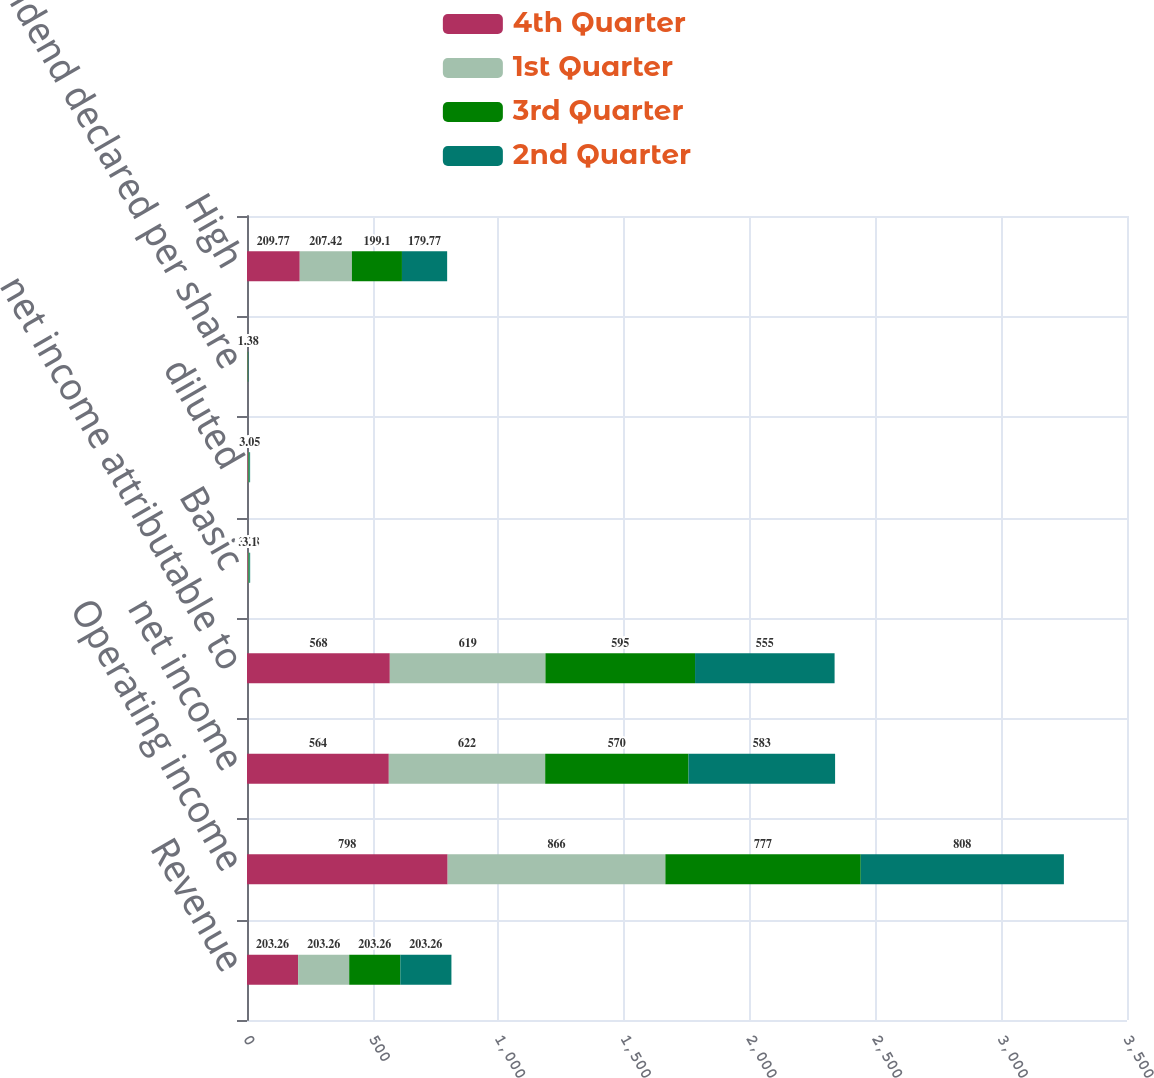Convert chart to OTSL. <chart><loc_0><loc_0><loc_500><loc_500><stacked_bar_chart><ecel><fcel>Revenue<fcel>Operating income<fcel>net income<fcel>net income attributable to<fcel>Basic<fcel>diluted<fcel>dividend declared per share<fcel>High<nl><fcel>4th Quarter<fcel>203.26<fcel>798<fcel>564<fcel>568<fcel>2.92<fcel>2.89<fcel>1.38<fcel>209.77<nl><fcel>1st Quarter<fcel>203.26<fcel>866<fcel>622<fcel>619<fcel>3.26<fcel>3.21<fcel>1.38<fcel>207.42<nl><fcel>3rd Quarter<fcel>203.26<fcel>777<fcel>570<fcel>595<fcel>3.28<fcel>3.23<fcel>1.38<fcel>199.1<nl><fcel>2nd Quarter<fcel>203.26<fcel>808<fcel>583<fcel>555<fcel>3.1<fcel>3.05<fcel>1.38<fcel>179.77<nl></chart> 